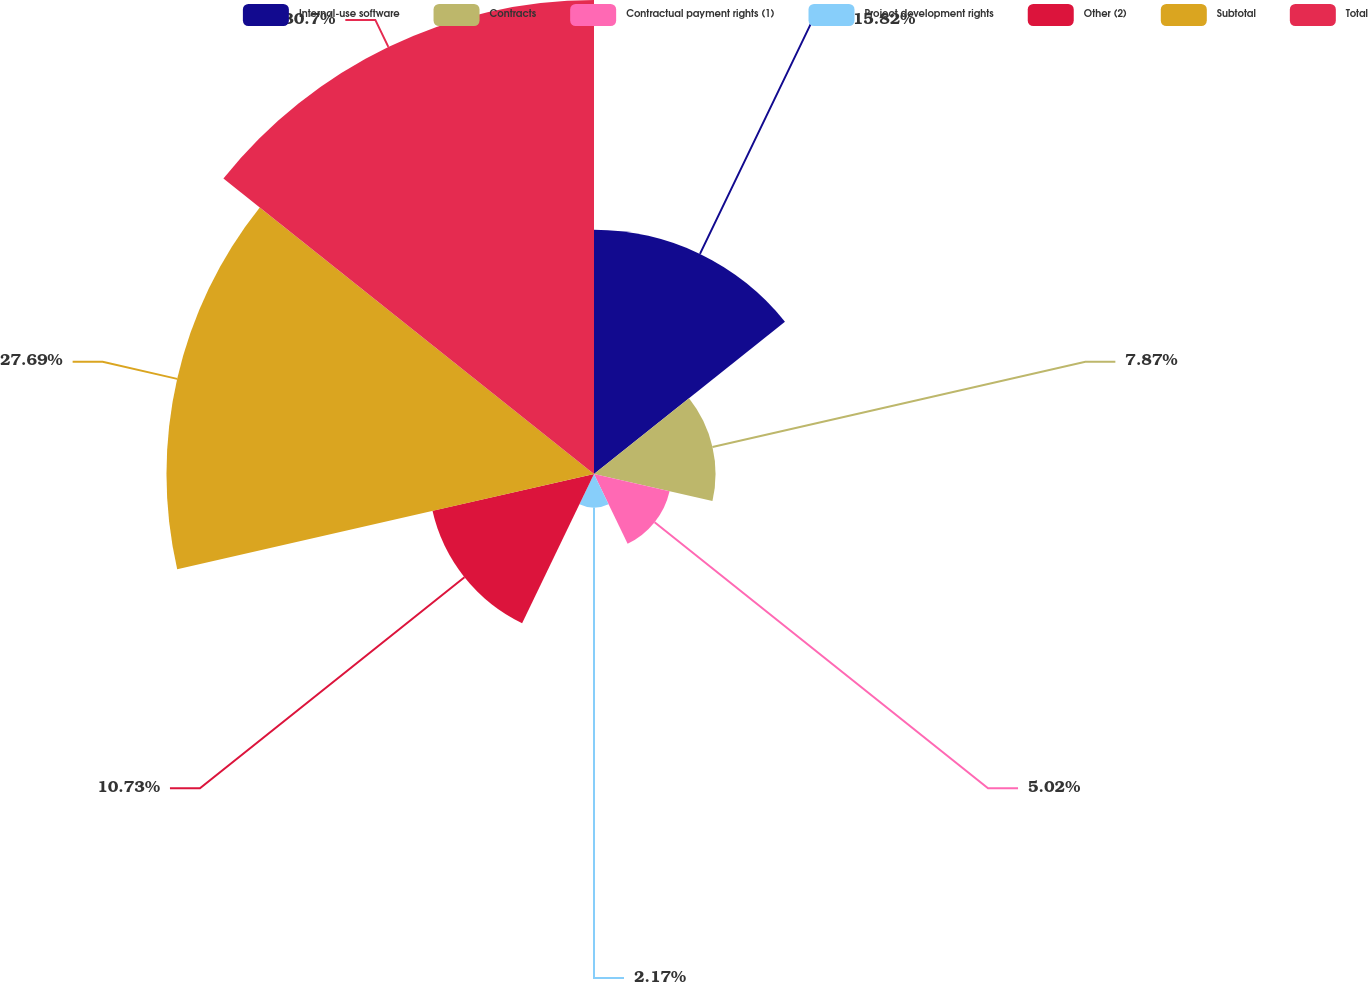<chart> <loc_0><loc_0><loc_500><loc_500><pie_chart><fcel>Internal-use software<fcel>Contracts<fcel>Contractual payment rights (1)<fcel>Project development rights<fcel>Other (2)<fcel>Subtotal<fcel>Total<nl><fcel>15.82%<fcel>7.87%<fcel>5.02%<fcel>2.17%<fcel>10.73%<fcel>27.69%<fcel>30.7%<nl></chart> 